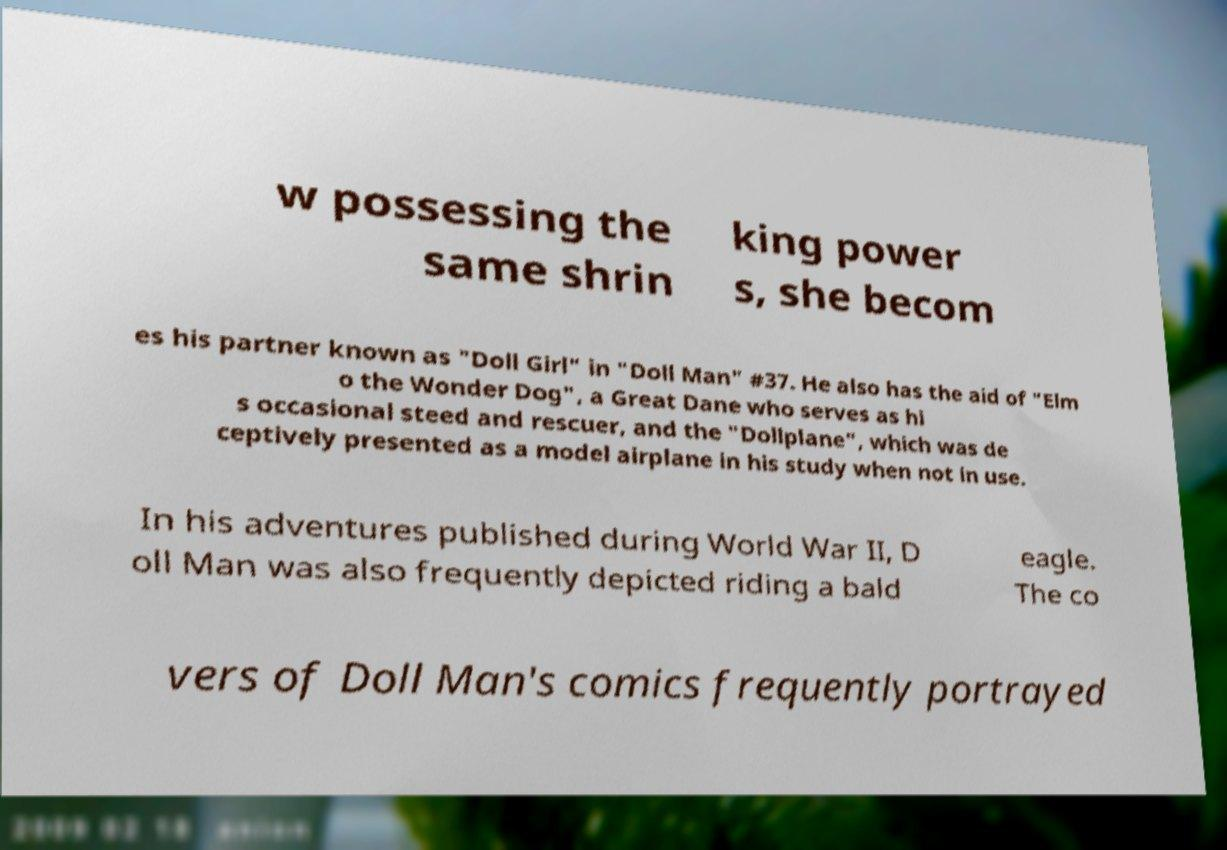There's text embedded in this image that I need extracted. Can you transcribe it verbatim? w possessing the same shrin king power s, she becom es his partner known as "Doll Girl" in "Doll Man" #37. He also has the aid of "Elm o the Wonder Dog", a Great Dane who serves as hi s occasional steed and rescuer, and the "Dollplane", which was de ceptively presented as a model airplane in his study when not in use. In his adventures published during World War II, D oll Man was also frequently depicted riding a bald eagle. The co vers of Doll Man's comics frequently portrayed 